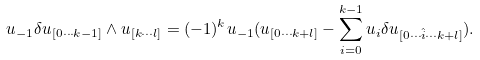Convert formula to latex. <formula><loc_0><loc_0><loc_500><loc_500>u _ { - 1 } \delta u _ { [ 0 \cdots k - 1 ] } \wedge u _ { [ k \cdots l ] } = ( - 1 ) ^ { k } u _ { - 1 } ( u _ { [ 0 \cdots k + l ] } - \sum _ { i = 0 } ^ { k - 1 } u _ { i } \delta u _ { [ 0 \cdots \hat { i } \cdots k + l ] } ) .</formula> 